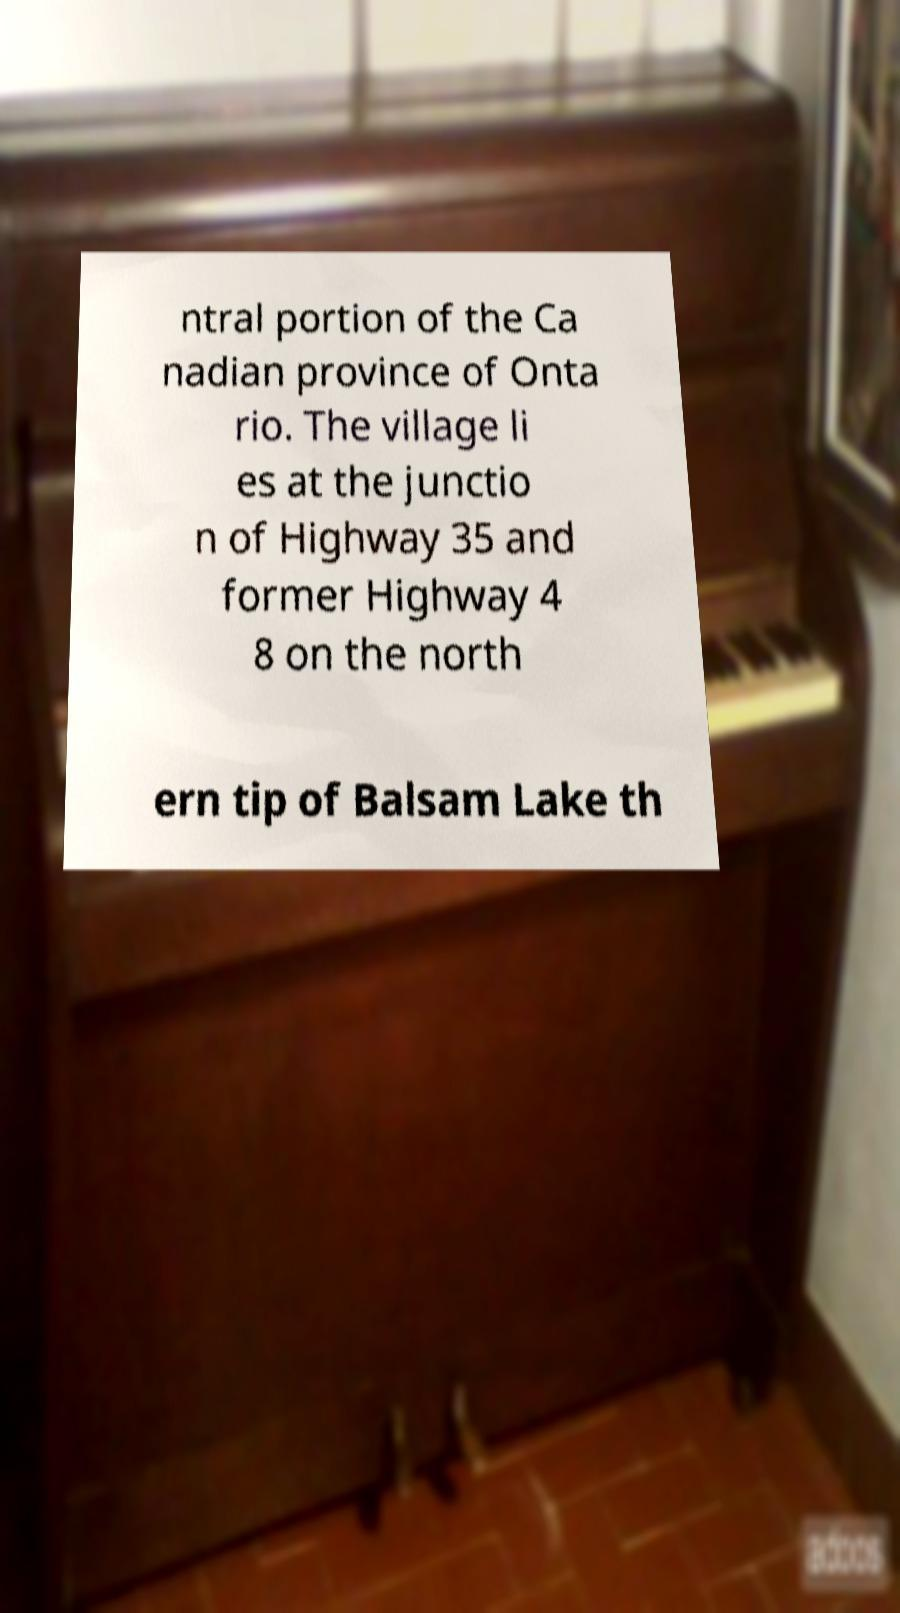Could you assist in decoding the text presented in this image and type it out clearly? ntral portion of the Ca nadian province of Onta rio. The village li es at the junctio n of Highway 35 and former Highway 4 8 on the north ern tip of Balsam Lake th 